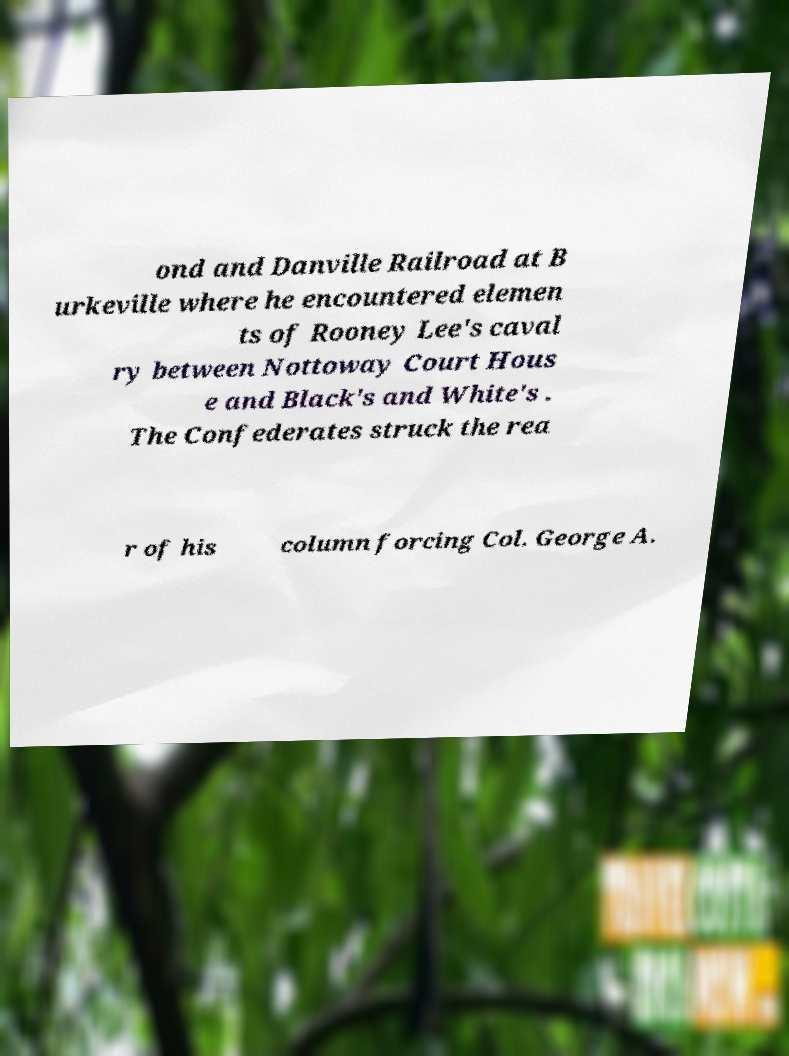Could you assist in decoding the text presented in this image and type it out clearly? ond and Danville Railroad at B urkeville where he encountered elemen ts of Rooney Lee's caval ry between Nottoway Court Hous e and Black's and White's . The Confederates struck the rea r of his column forcing Col. George A. 